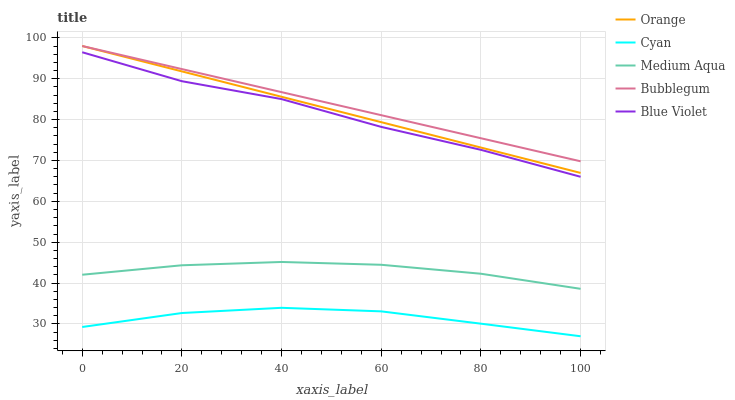Does Cyan have the minimum area under the curve?
Answer yes or no. Yes. Does Bubblegum have the maximum area under the curve?
Answer yes or no. Yes. Does Medium Aqua have the minimum area under the curve?
Answer yes or no. No. Does Medium Aqua have the maximum area under the curve?
Answer yes or no. No. Is Orange the smoothest?
Answer yes or no. Yes. Is Blue Violet the roughest?
Answer yes or no. Yes. Is Cyan the smoothest?
Answer yes or no. No. Is Cyan the roughest?
Answer yes or no. No. Does Cyan have the lowest value?
Answer yes or no. Yes. Does Medium Aqua have the lowest value?
Answer yes or no. No. Does Bubblegum have the highest value?
Answer yes or no. Yes. Does Medium Aqua have the highest value?
Answer yes or no. No. Is Medium Aqua less than Blue Violet?
Answer yes or no. Yes. Is Bubblegum greater than Cyan?
Answer yes or no. Yes. Does Bubblegum intersect Orange?
Answer yes or no. Yes. Is Bubblegum less than Orange?
Answer yes or no. No. Is Bubblegum greater than Orange?
Answer yes or no. No. Does Medium Aqua intersect Blue Violet?
Answer yes or no. No. 